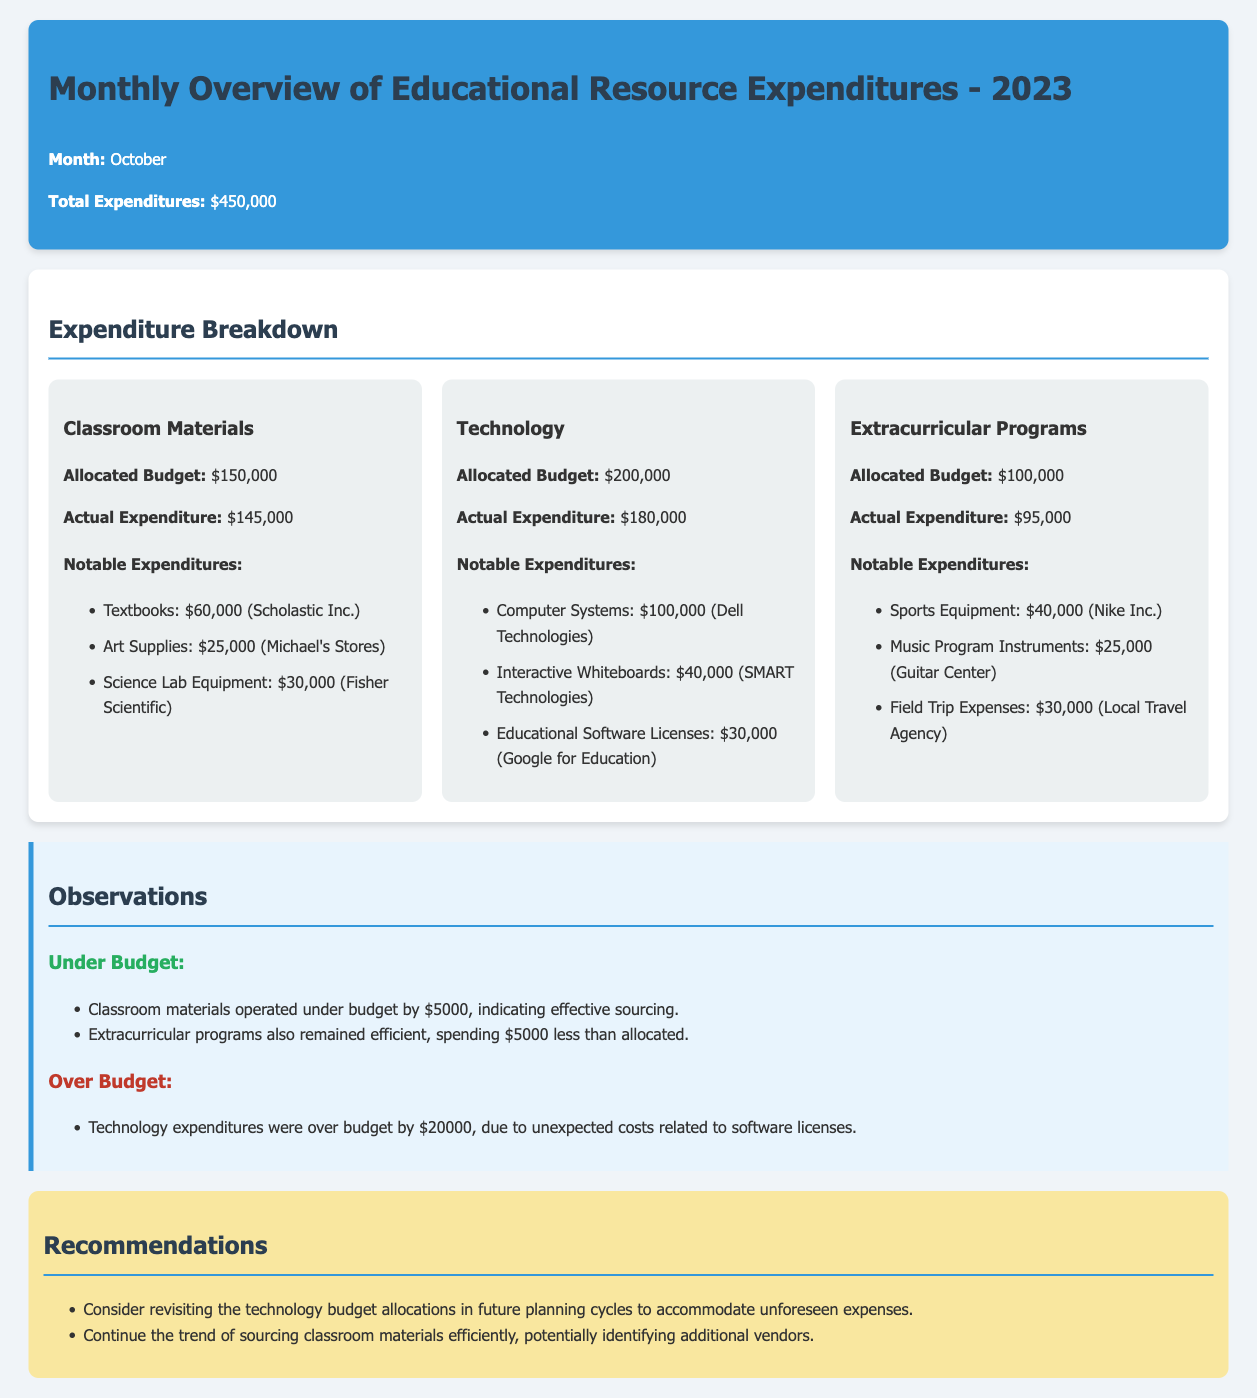What is the total expenditure for October 2023? The total expenditure is indicated in the report as the amount spent during October.
Answer: $450,000 What is the allocated budget for classroom materials? The allocated budget for classroom materials is specified in the document under the expenditure breakdown section.
Answer: $150,000 How much was spent on technology? The actual expenditure for technology is clearly listed in the technology expenditure card of the report.
Answer: $180,000 What was the notable expenditure for science lab equipment? The report lists this specific expenditure under notable expenditures for classroom materials.
Answer: $30,000 Which category had an over-budget expenditure? The document indicates this category under the observations section that details budget performance.
Answer: Technology What is the total under-budget amount for classroom materials? The report mentions the amount by which classroom materials were under budget compared to the allocated budget.
Answer: $5,000 How much was allocated for extracurricular programs? The allocated budget for extracurricular programs is shown in the expenditure breakdown section.
Answer: $100,000 What is one recommendation made in the report? The recommendations section lists suggestions based on the expenditure observations.
Answer: Revisit technology budget allocations How much was spent on sports equipment? This amount is provided under notable expenditures for extracurricular programs.
Answer: $40,000 